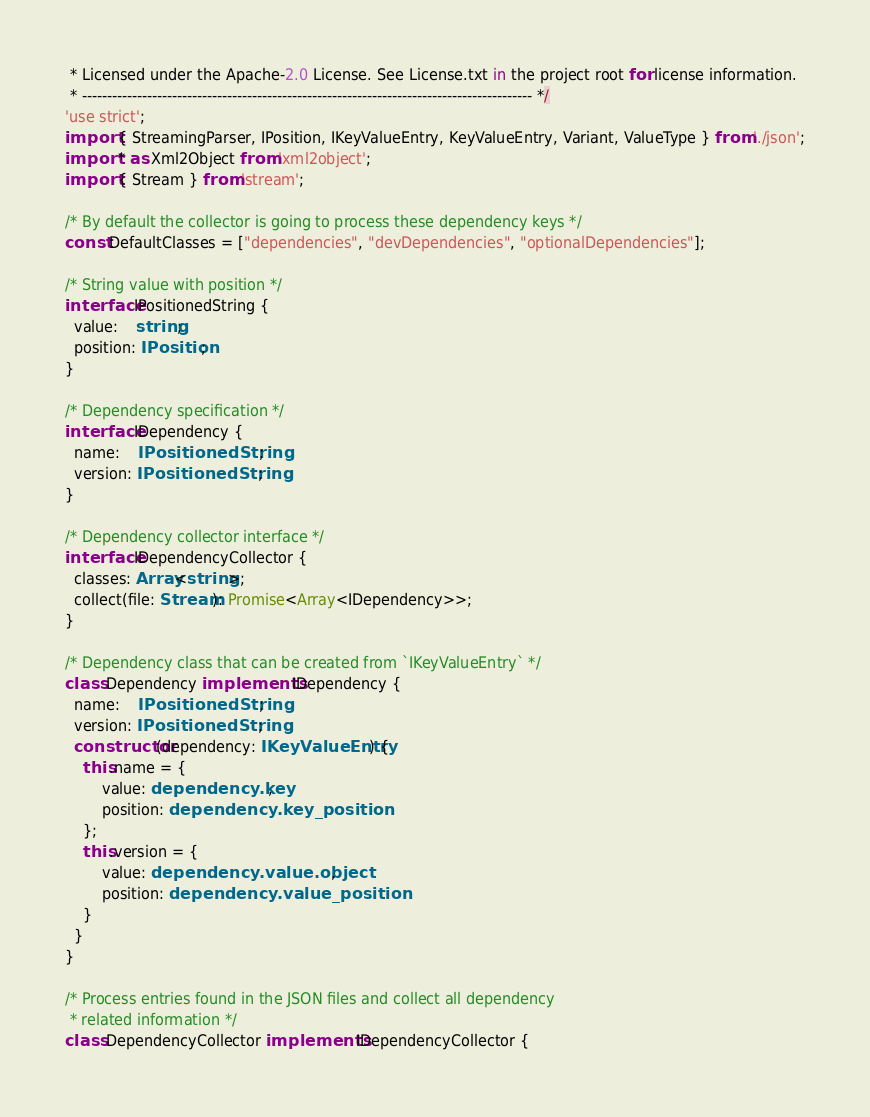<code> <loc_0><loc_0><loc_500><loc_500><_TypeScript_> * Licensed under the Apache-2.0 License. See License.txt in the project root for license information.
 * ------------------------------------------------------------------------------------------ */
'use strict';
import { StreamingParser, IPosition, IKeyValueEntry, KeyValueEntry, Variant, ValueType } from './json';
import * as Xml2Object from 'xml2object';
import { Stream } from 'stream';

/* By default the collector is going to process these dependency keys */
const DefaultClasses = ["dependencies", "devDependencies", "optionalDependencies"];

/* String value with position */
interface IPositionedString {
  value:    string;
  position: IPosition;
}

/* Dependency specification */
interface IDependency {
  name:    IPositionedString;
  version: IPositionedString;
}

/* Dependency collector interface */
interface IDependencyCollector {
  classes: Array<string>;
  collect(file: Stream): Promise<Array<IDependency>>;
}

/* Dependency class that can be created from `IKeyValueEntry` */
class Dependency implements IDependency {
  name:    IPositionedString;
  version: IPositionedString;
  constructor(dependency: IKeyValueEntry) {
    this.name = {
        value: dependency.key, 
        position: dependency.key_position
    }; 
    this.version = {
        value: dependency.value.object, 
        position: dependency.value_position
    }
  }
}

/* Process entries found in the JSON files and collect all dependency
 * related information */
class DependencyCollector implements IDependencyCollector {</code> 